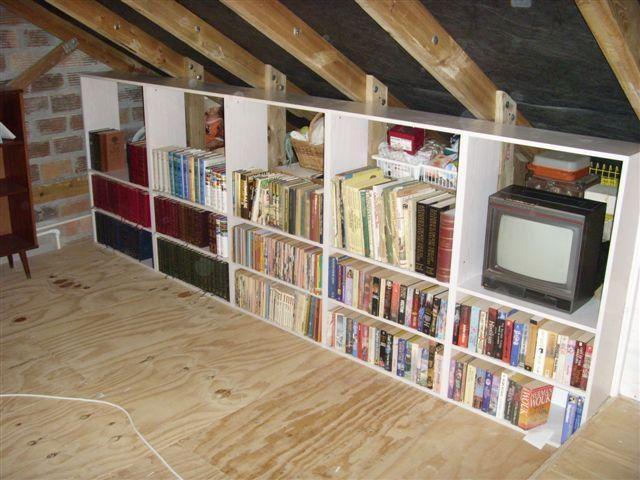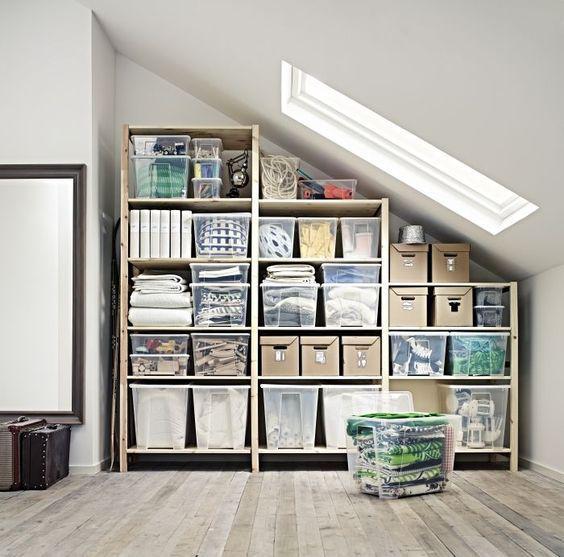The first image is the image on the left, the second image is the image on the right. For the images shown, is this caption "In one image, a couch with throw pillows, a coffee table and at least one side chair form a seating area in front of a wall of bookshelves." true? Answer yes or no. No. The first image is the image on the left, the second image is the image on the right. For the images shown, is this caption "An image shows a square skylight in the peaked ceiling of a room with shelves along the wall." true? Answer yes or no. Yes. 